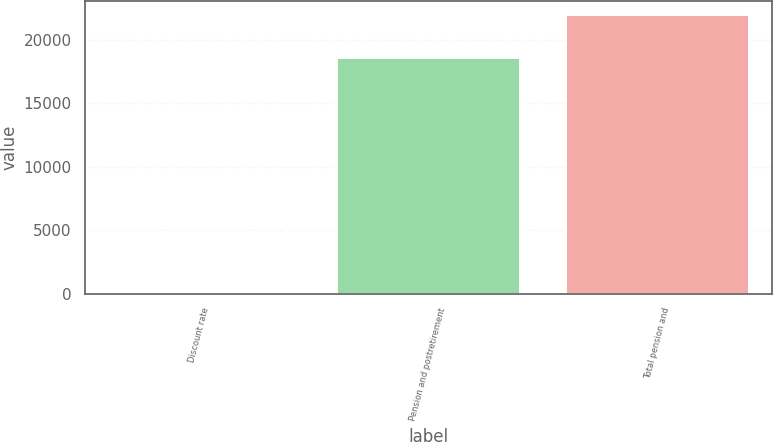<chart> <loc_0><loc_0><loc_500><loc_500><bar_chart><fcel>Discount rate<fcel>Pension and postretirement<fcel>Total pension and<nl><fcel>4<fcel>18587<fcel>21935<nl></chart> 